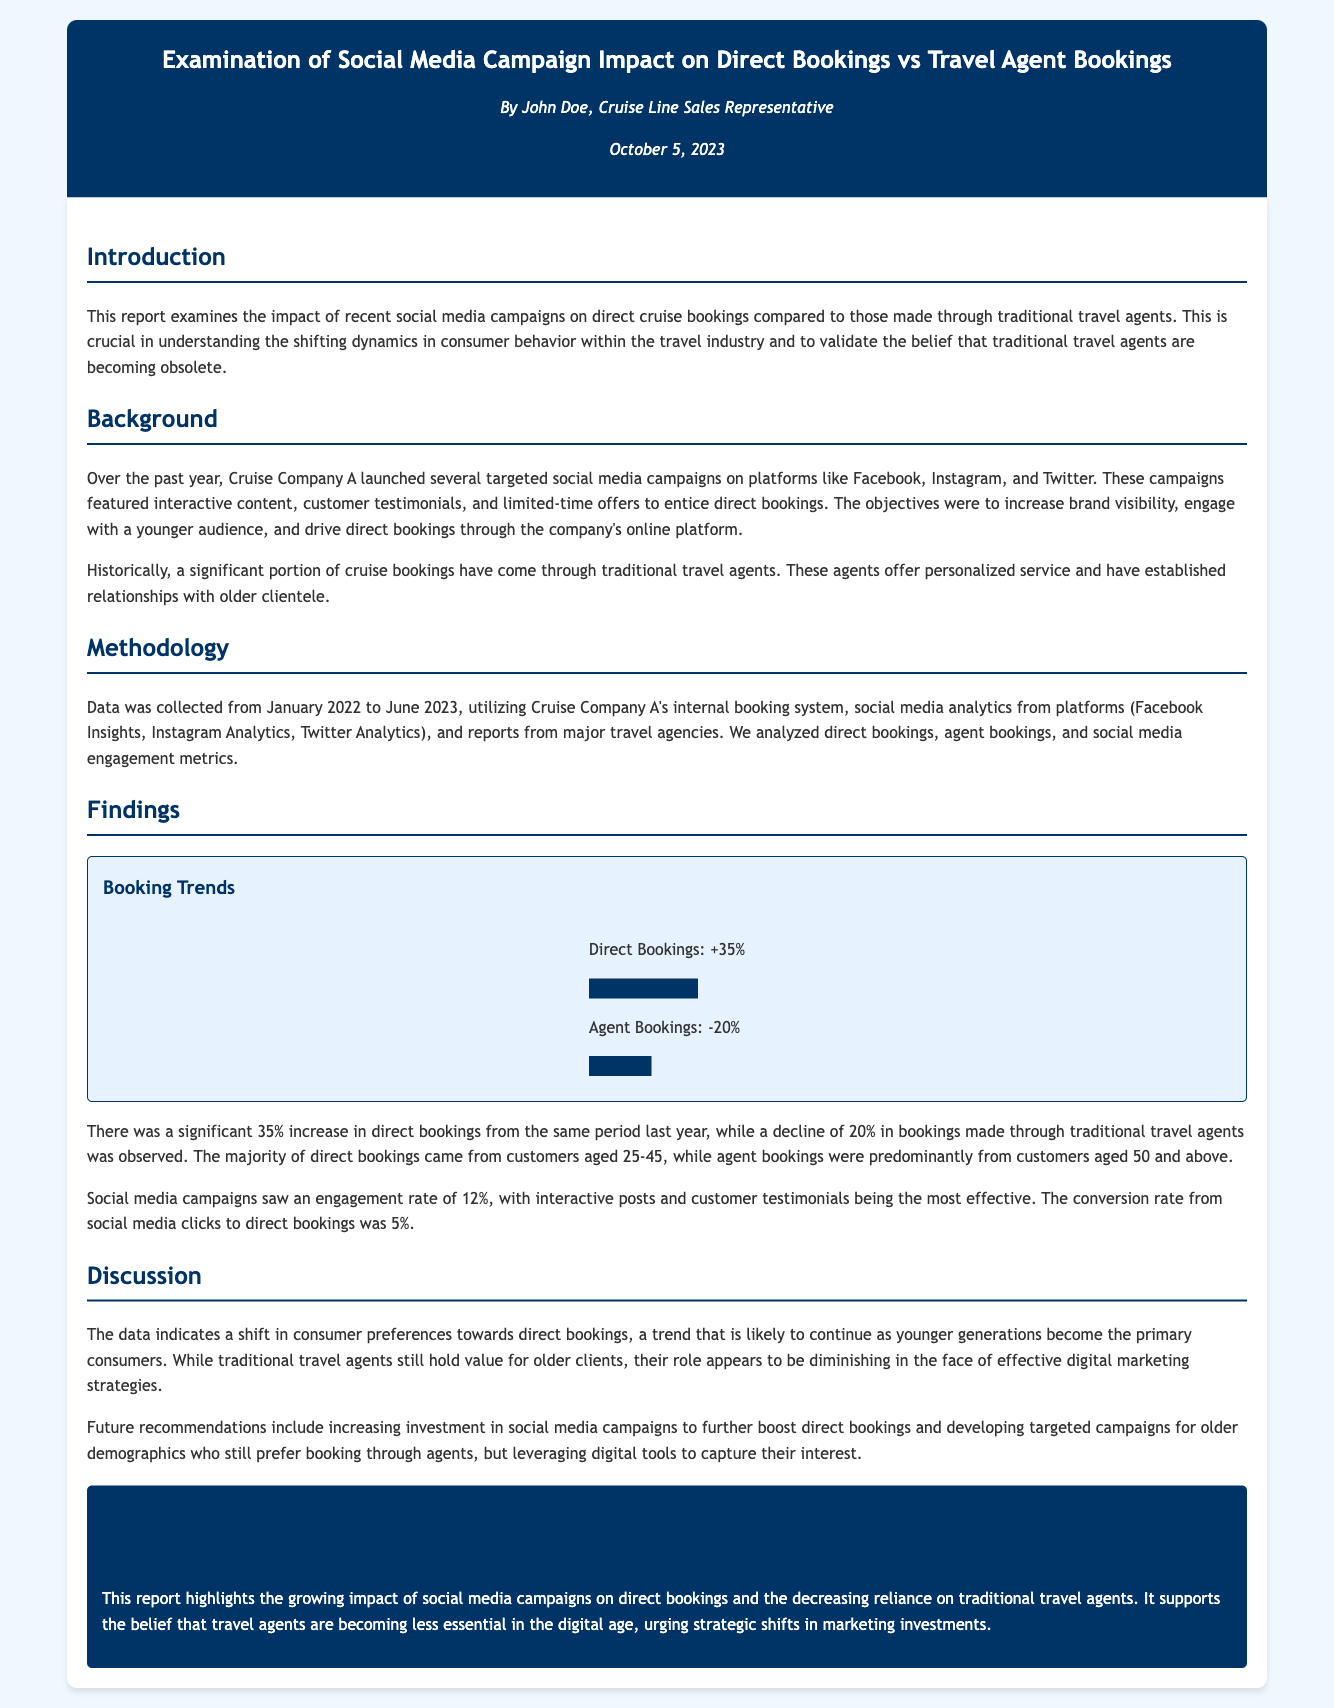What is the percentage increase in direct bookings? The report states there was a significant 35% increase in direct bookings from the same period last year.
Answer: 35% What is the percentage decrease in agent bookings? The document mentions a decline of 20% in bookings made through traditional travel agents.
Answer: 20% What is the engagement rate of the social media campaigns? The report indicates that social media campaigns saw an engagement rate of 12%.
Answer: 12% What age group predominantly made direct bookings? It is noted that the majority of direct bookings came from customers aged 25-45.
Answer: 25-45 What was the conversion rate from social media clicks to direct bookings? According to the findings, the conversion rate from social media clicks to direct bookings was 5%.
Answer: 5% Who is the author of the report? The document lists John Doe as the author of the report.
Answer: John Doe What is the primary focus of the report? The main focus of the report is examining the impact of social media campaigns on direct cruise bookings compared to traditional travel agent bookings.
Answer: Impact of social media campaigns What does the report suggest about the role of traditional travel agents? The findings indicate that the role of traditional travel agents appears to be diminishing in the face of effective digital marketing strategies.
Answer: Diminishing What month and year was the report published? The publication date of the report is mentioned as October 5, 2023.
Answer: October 5, 2023 